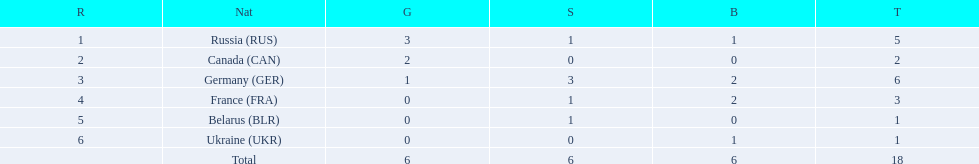Which countries had one or more gold medals? Russia (RUS), Canada (CAN), Germany (GER). Of these countries, which had at least one silver medal? Russia (RUS), Germany (GER). Of the remaining countries, who had more medals overall? Germany (GER). 